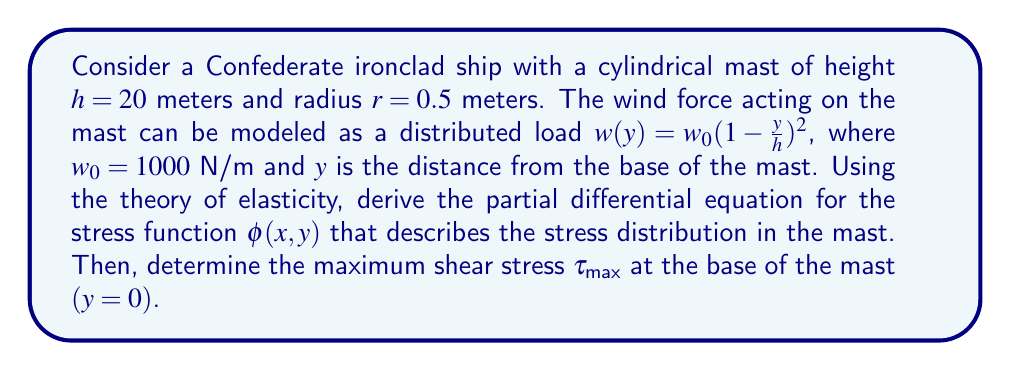Help me with this question. To solve this problem, we'll follow these steps:

1) First, we need to derive the partial differential equation for the stress function $\phi(x,y)$. In cylindrical coordinates, the equation of equilibrium in terms of the stress function is:

   $$\nabla^4 \phi = 0$$

   This is known as the biharmonic equation.

2) The boundary conditions for this problem are:
   - At $r = 0.5$ m (surface of the mast), the radial stress $\sigma_r = -w(y)\cos\theta$
   - At $r = 0.5$ m, the shear stress $\tau_{r\theta} = w(y)\sin\theta$

3) The general solution for $\phi(r,\theta)$ in polar coordinates that satisfies the biharmonic equation is:

   $$\phi = (A_0r^2 + B_0\ln r + C_0r^2\ln r + D_0)\theta + \sum_{n=1}^{\infty}(A_nr^{n+2} + B_nr^n + C_nr^{-n+2} + D_nr^{-n})\sin n\theta$$

4) Applying the boundary conditions and solving for the constants, we find that only the $n=1$ term is non-zero, and:

   $$A_1 = -\frac{w(y)}{8}, B_1 = -\frac{w(y)r^2}{4}, C_1 = D_1 = 0$$

5) Therefore, the stress function is:

   $$\phi(r,\theta,y) = (-\frac{w(y)r^3}{8} - \frac{w(y)r^2}{4})\sin\theta$$

6) The shear stress $\tau_{r\theta}$ is given by:

   $$\tau_{r\theta} = -\frac{\partial}{\partial r}(\frac{1}{r}\frac{\partial \phi}{\partial \theta})$$

7) Substituting our stress function and evaluating at $r = 0.5$ m:

   $$\tau_{r\theta} = w(y)\sin\theta$$

8) The maximum shear stress occurs at $\theta = 90°$ or $270°$, where $\sin\theta = \pm1$. At the base $(y=0)$, $w(y) = w_0 = 1000$ N/m.

Therefore, the maximum shear stress at the base is:

$$\tau_{max} = |w_0| = 1000 \text{ N/m}^2$$
Answer: The maximum shear stress at the base of the mast is $\tau_{max} = 1000 \text{ N/m}^2$. 